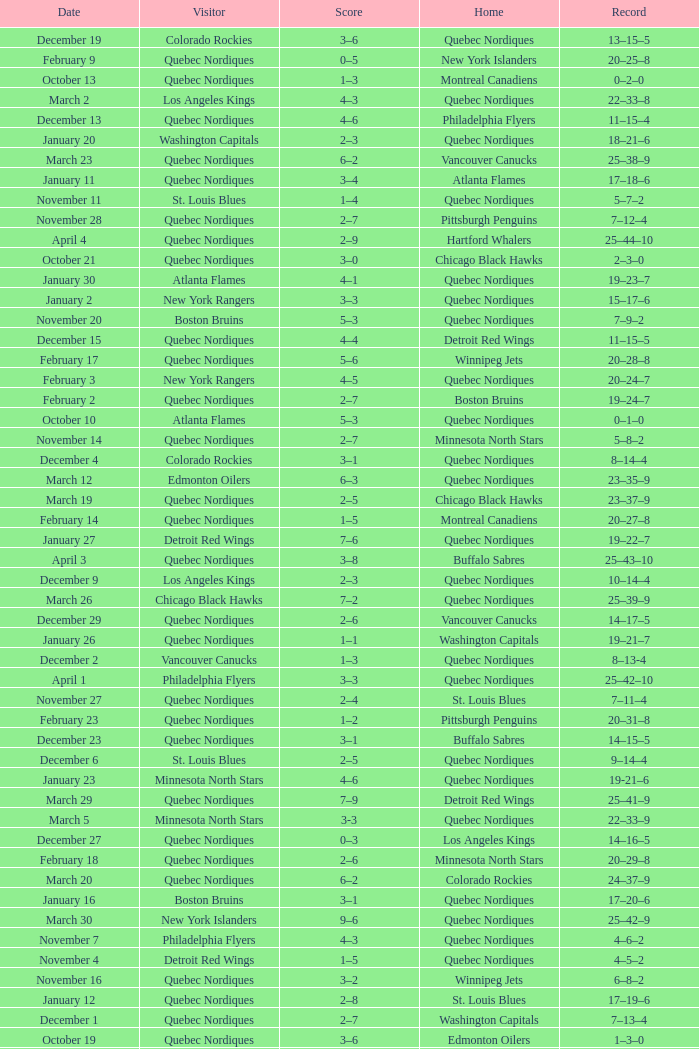Which Date has a Score of 2–7, and a Record of 5–8–2? November 14. 